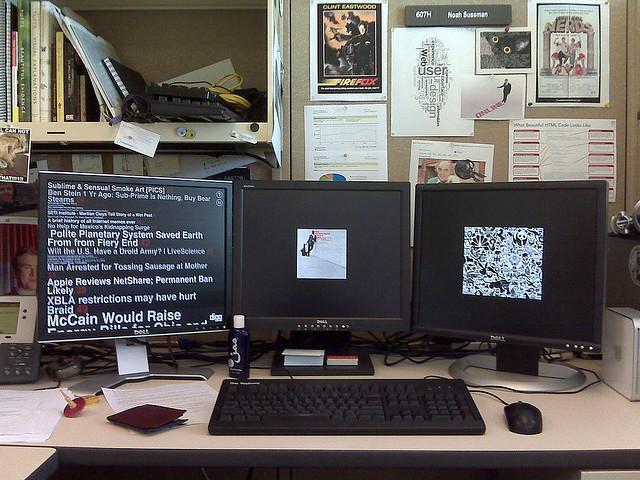How many screens?
Give a very brief answer. 3. How many books can be seen?
Give a very brief answer. 1. How many tvs can you see?
Give a very brief answer. 3. 